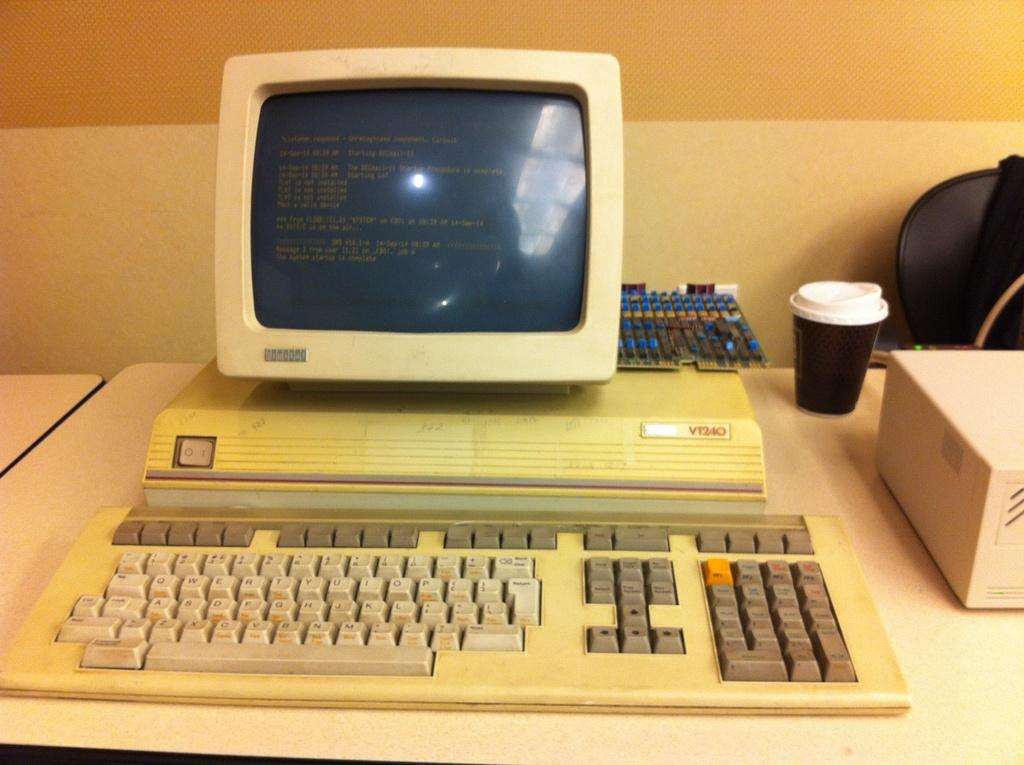<image>
Share a concise interpretation of the image provided. the number 240 is on the computer item 